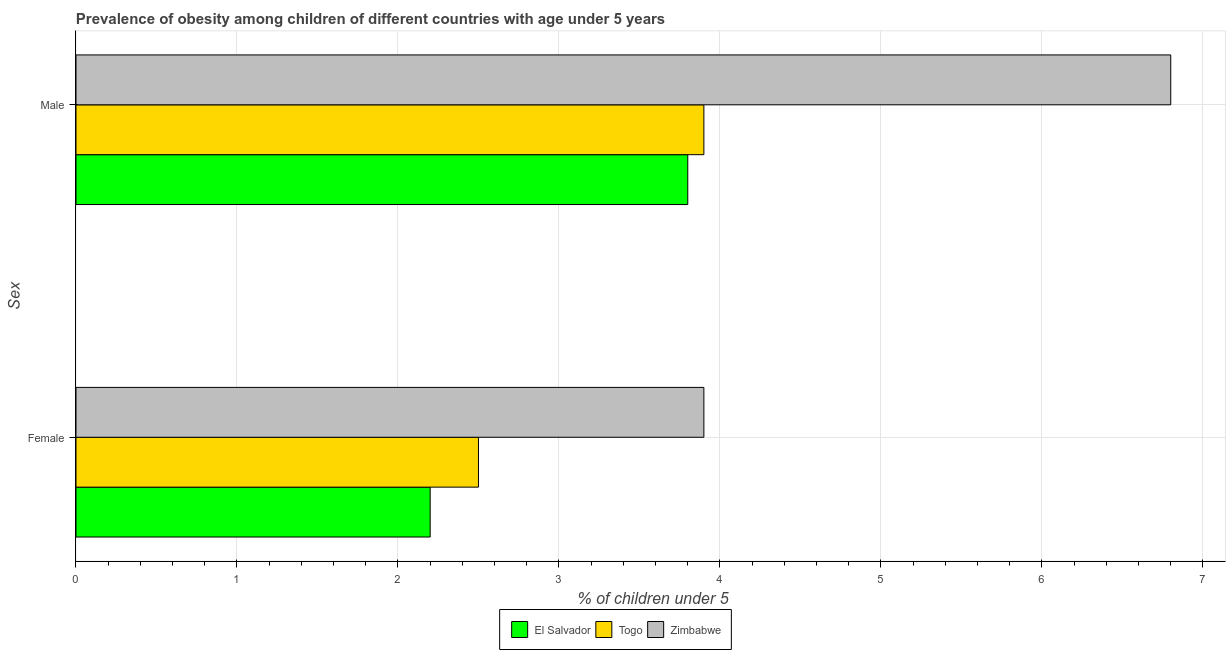How many different coloured bars are there?
Your response must be concise. 3. How many groups of bars are there?
Your response must be concise. 2. What is the label of the 1st group of bars from the top?
Ensure brevity in your answer.  Male. What is the percentage of obese male children in El Salvador?
Your answer should be very brief. 3.8. Across all countries, what is the maximum percentage of obese male children?
Offer a terse response. 6.8. Across all countries, what is the minimum percentage of obese female children?
Offer a terse response. 2.2. In which country was the percentage of obese male children maximum?
Provide a succinct answer. Zimbabwe. In which country was the percentage of obese male children minimum?
Offer a terse response. El Salvador. What is the total percentage of obese female children in the graph?
Give a very brief answer. 8.6. What is the difference between the percentage of obese male children in El Salvador and that in Togo?
Provide a succinct answer. -0.1. What is the average percentage of obese male children per country?
Offer a very short reply. 4.83. What is the difference between the percentage of obese male children and percentage of obese female children in El Salvador?
Keep it short and to the point. 1.6. In how many countries, is the percentage of obese male children greater than 2.8 %?
Your answer should be compact. 3. What is the ratio of the percentage of obese female children in Zimbabwe to that in El Salvador?
Keep it short and to the point. 1.77. What does the 3rd bar from the top in Female represents?
Your answer should be very brief. El Salvador. What does the 1st bar from the bottom in Female represents?
Keep it short and to the point. El Salvador. How many bars are there?
Keep it short and to the point. 6. Are all the bars in the graph horizontal?
Provide a short and direct response. Yes. Are the values on the major ticks of X-axis written in scientific E-notation?
Provide a succinct answer. No. Does the graph contain grids?
Offer a very short reply. Yes. Where does the legend appear in the graph?
Give a very brief answer. Bottom center. What is the title of the graph?
Ensure brevity in your answer.  Prevalence of obesity among children of different countries with age under 5 years. What is the label or title of the X-axis?
Your response must be concise.  % of children under 5. What is the label or title of the Y-axis?
Give a very brief answer. Sex. What is the  % of children under 5 of El Salvador in Female?
Your answer should be very brief. 2.2. What is the  % of children under 5 in Togo in Female?
Make the answer very short. 2.5. What is the  % of children under 5 of Zimbabwe in Female?
Your answer should be compact. 3.9. What is the  % of children under 5 in El Salvador in Male?
Your answer should be compact. 3.8. What is the  % of children under 5 in Togo in Male?
Provide a succinct answer. 3.9. What is the  % of children under 5 in Zimbabwe in Male?
Provide a succinct answer. 6.8. Across all Sex, what is the maximum  % of children under 5 of El Salvador?
Provide a short and direct response. 3.8. Across all Sex, what is the maximum  % of children under 5 of Togo?
Keep it short and to the point. 3.9. Across all Sex, what is the maximum  % of children under 5 in Zimbabwe?
Ensure brevity in your answer.  6.8. Across all Sex, what is the minimum  % of children under 5 of El Salvador?
Your answer should be very brief. 2.2. Across all Sex, what is the minimum  % of children under 5 of Togo?
Ensure brevity in your answer.  2.5. Across all Sex, what is the minimum  % of children under 5 in Zimbabwe?
Ensure brevity in your answer.  3.9. What is the difference between the  % of children under 5 in El Salvador in Female and that in Male?
Your answer should be very brief. -1.6. What is the difference between the  % of children under 5 of El Salvador in Female and the  % of children under 5 of Zimbabwe in Male?
Provide a short and direct response. -4.6. What is the average  % of children under 5 in El Salvador per Sex?
Your answer should be compact. 3. What is the average  % of children under 5 in Togo per Sex?
Offer a very short reply. 3.2. What is the average  % of children under 5 in Zimbabwe per Sex?
Offer a terse response. 5.35. What is the difference between the  % of children under 5 in El Salvador and  % of children under 5 in Zimbabwe in Male?
Make the answer very short. -3. What is the difference between the  % of children under 5 in Togo and  % of children under 5 in Zimbabwe in Male?
Your response must be concise. -2.9. What is the ratio of the  % of children under 5 in El Salvador in Female to that in Male?
Give a very brief answer. 0.58. What is the ratio of the  % of children under 5 in Togo in Female to that in Male?
Offer a terse response. 0.64. What is the ratio of the  % of children under 5 of Zimbabwe in Female to that in Male?
Ensure brevity in your answer.  0.57. What is the difference between the highest and the lowest  % of children under 5 in El Salvador?
Your answer should be very brief. 1.6. What is the difference between the highest and the lowest  % of children under 5 in Togo?
Keep it short and to the point. 1.4. 